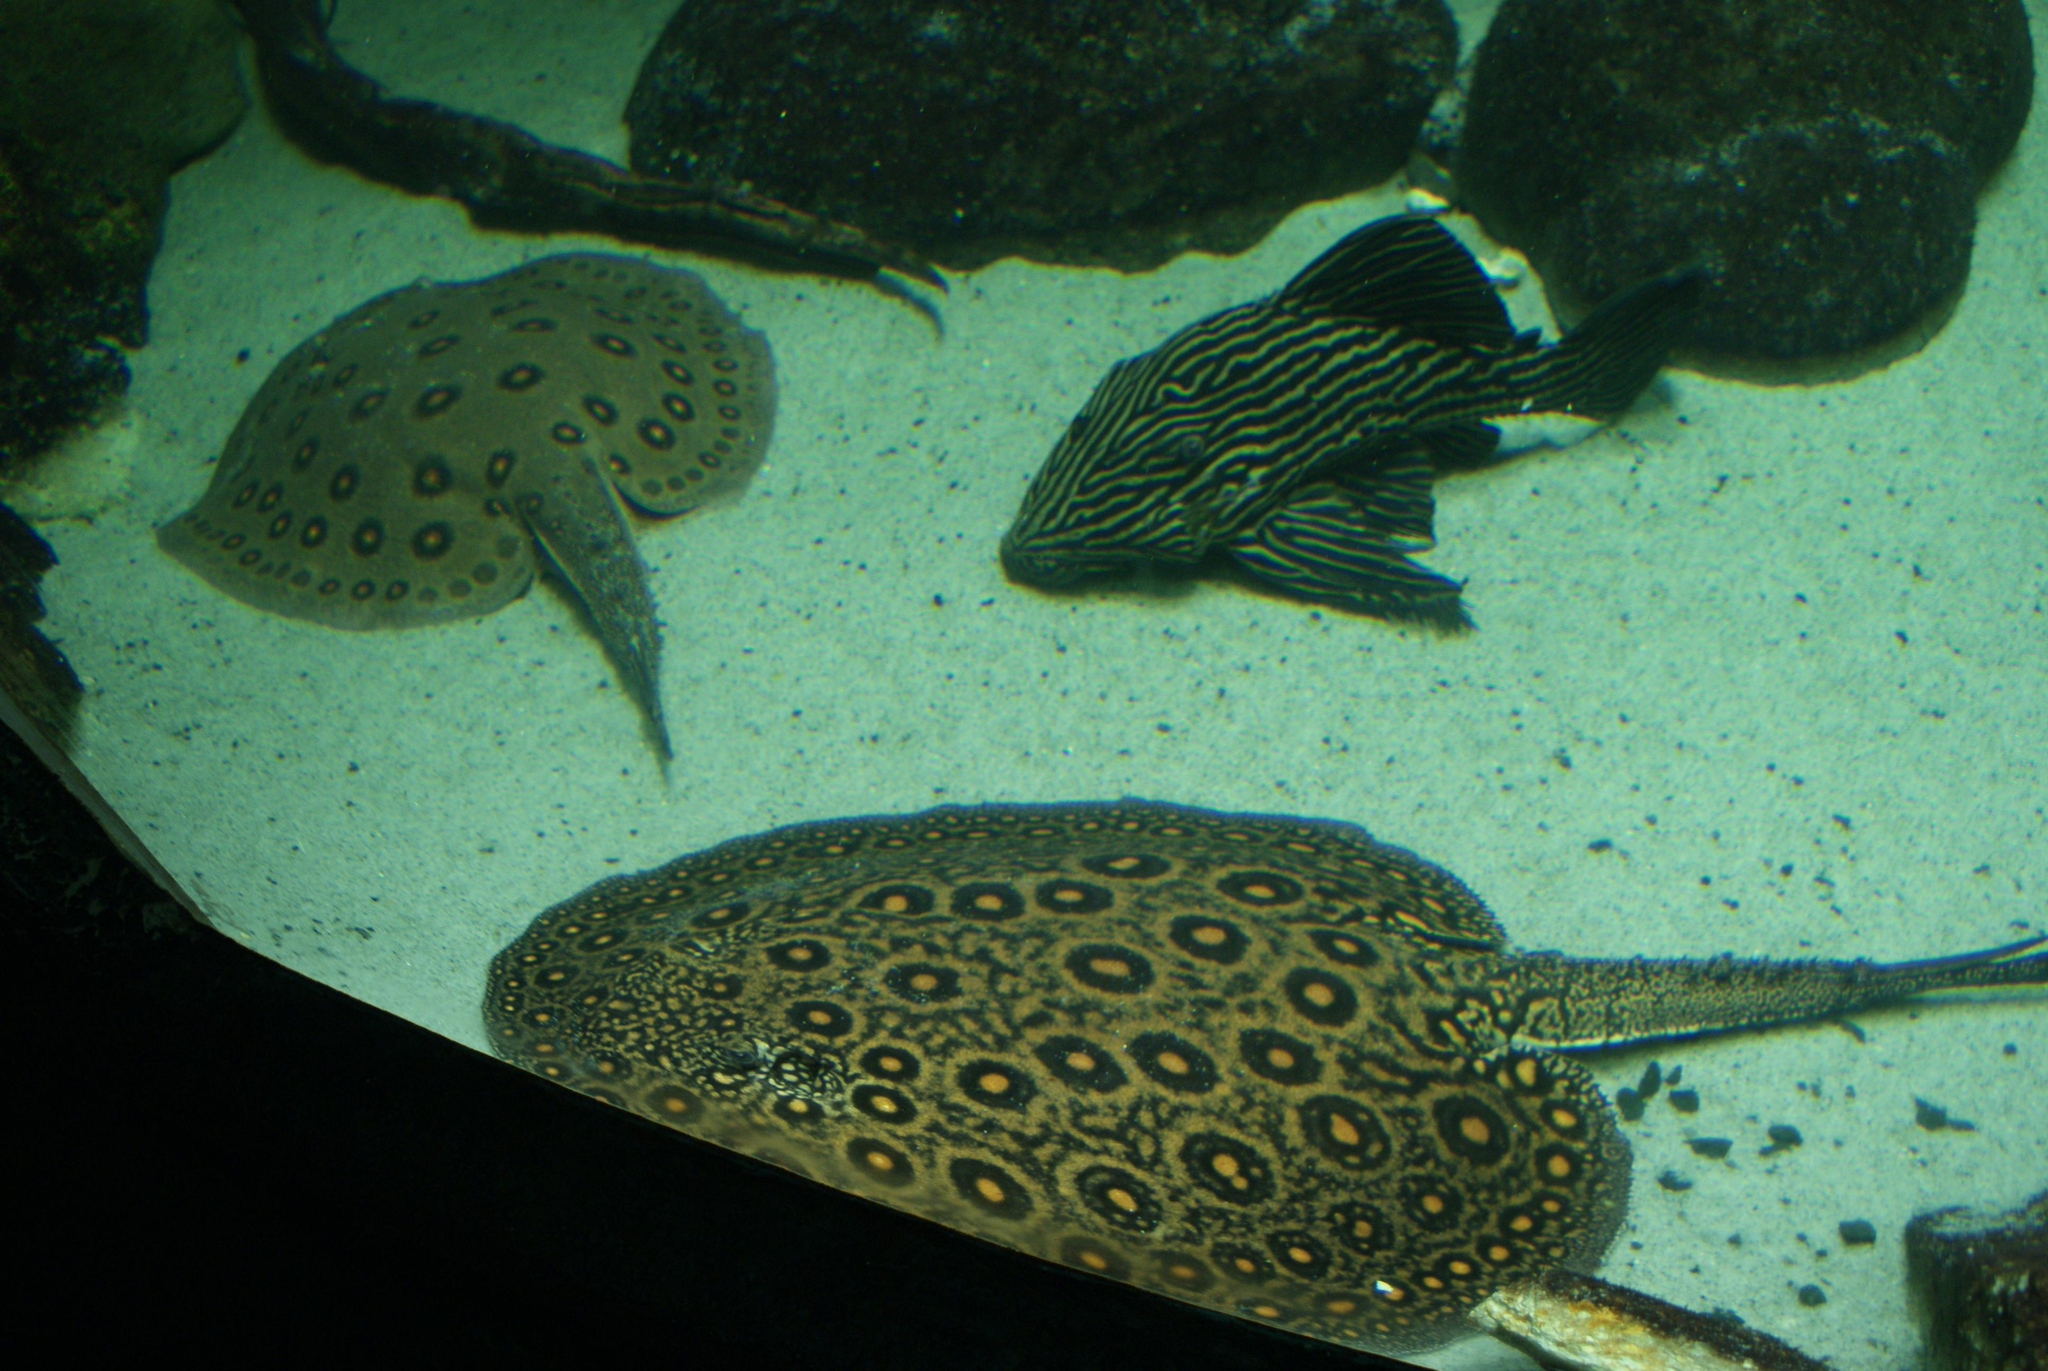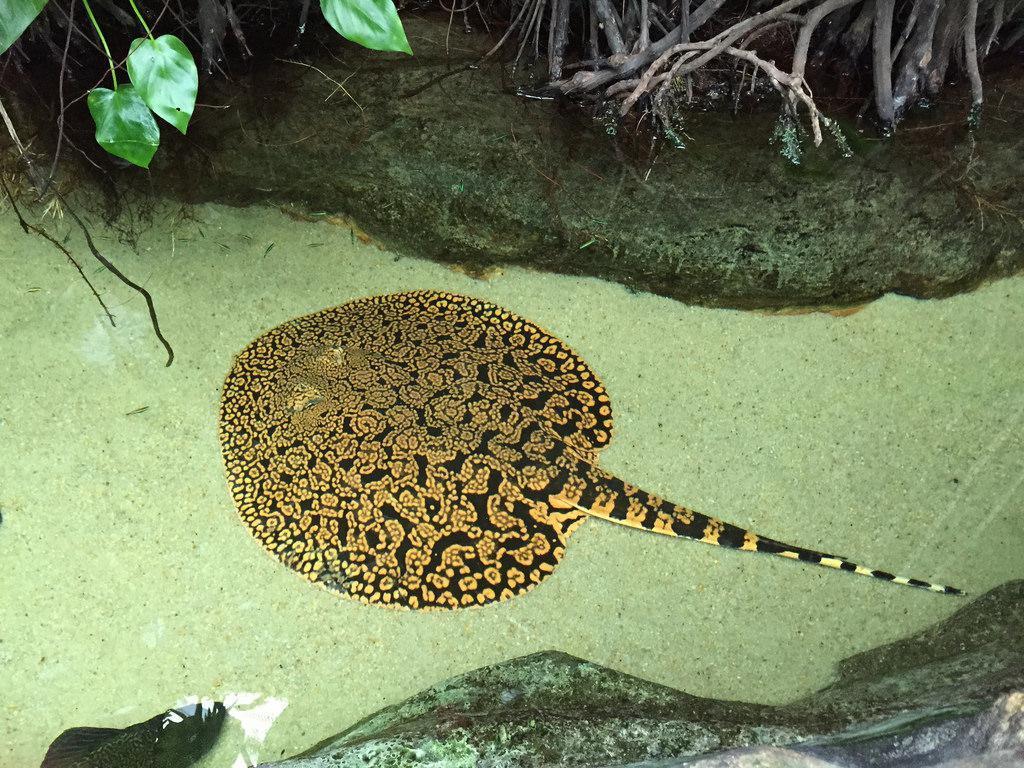The first image is the image on the left, the second image is the image on the right. For the images shown, is this caption "No more than 2 animals in any of the pictures" true? Answer yes or no. No. 